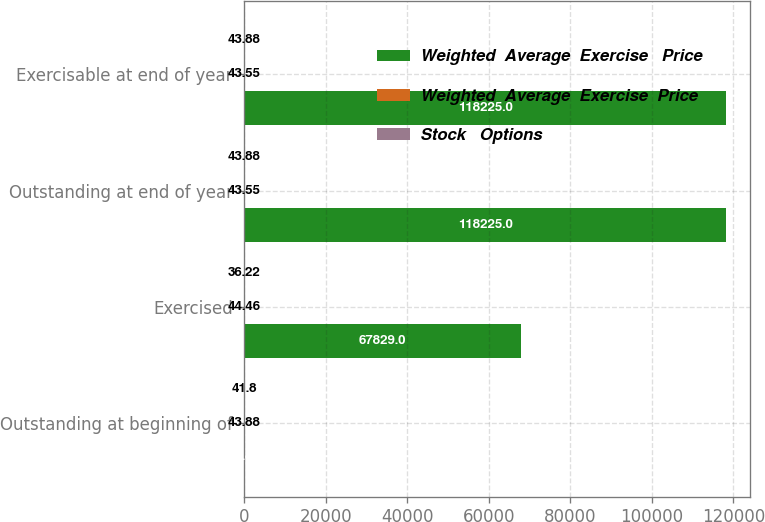Convert chart. <chart><loc_0><loc_0><loc_500><loc_500><stacked_bar_chart><ecel><fcel>Outstanding at beginning of<fcel>Exercised<fcel>Outstanding at end of year<fcel>Exercisable at end of year<nl><fcel>Weighted  Average  Exercise   Price<fcel>43.88<fcel>67829<fcel>118225<fcel>118225<nl><fcel>Weighted  Average  Exercise  Price<fcel>43.88<fcel>44.46<fcel>43.55<fcel>43.55<nl><fcel>Stock   Options<fcel>41.8<fcel>36.22<fcel>43.88<fcel>43.88<nl></chart> 